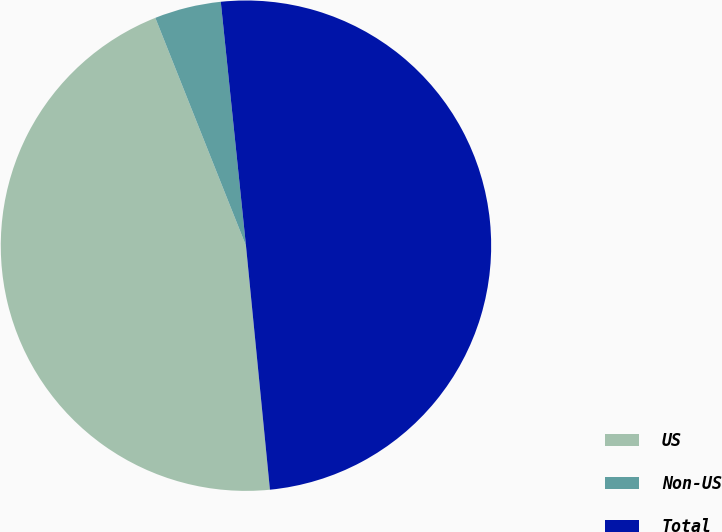Convert chart to OTSL. <chart><loc_0><loc_0><loc_500><loc_500><pie_chart><fcel>US<fcel>Non-US<fcel>Total<nl><fcel>45.53%<fcel>4.39%<fcel>50.08%<nl></chart> 